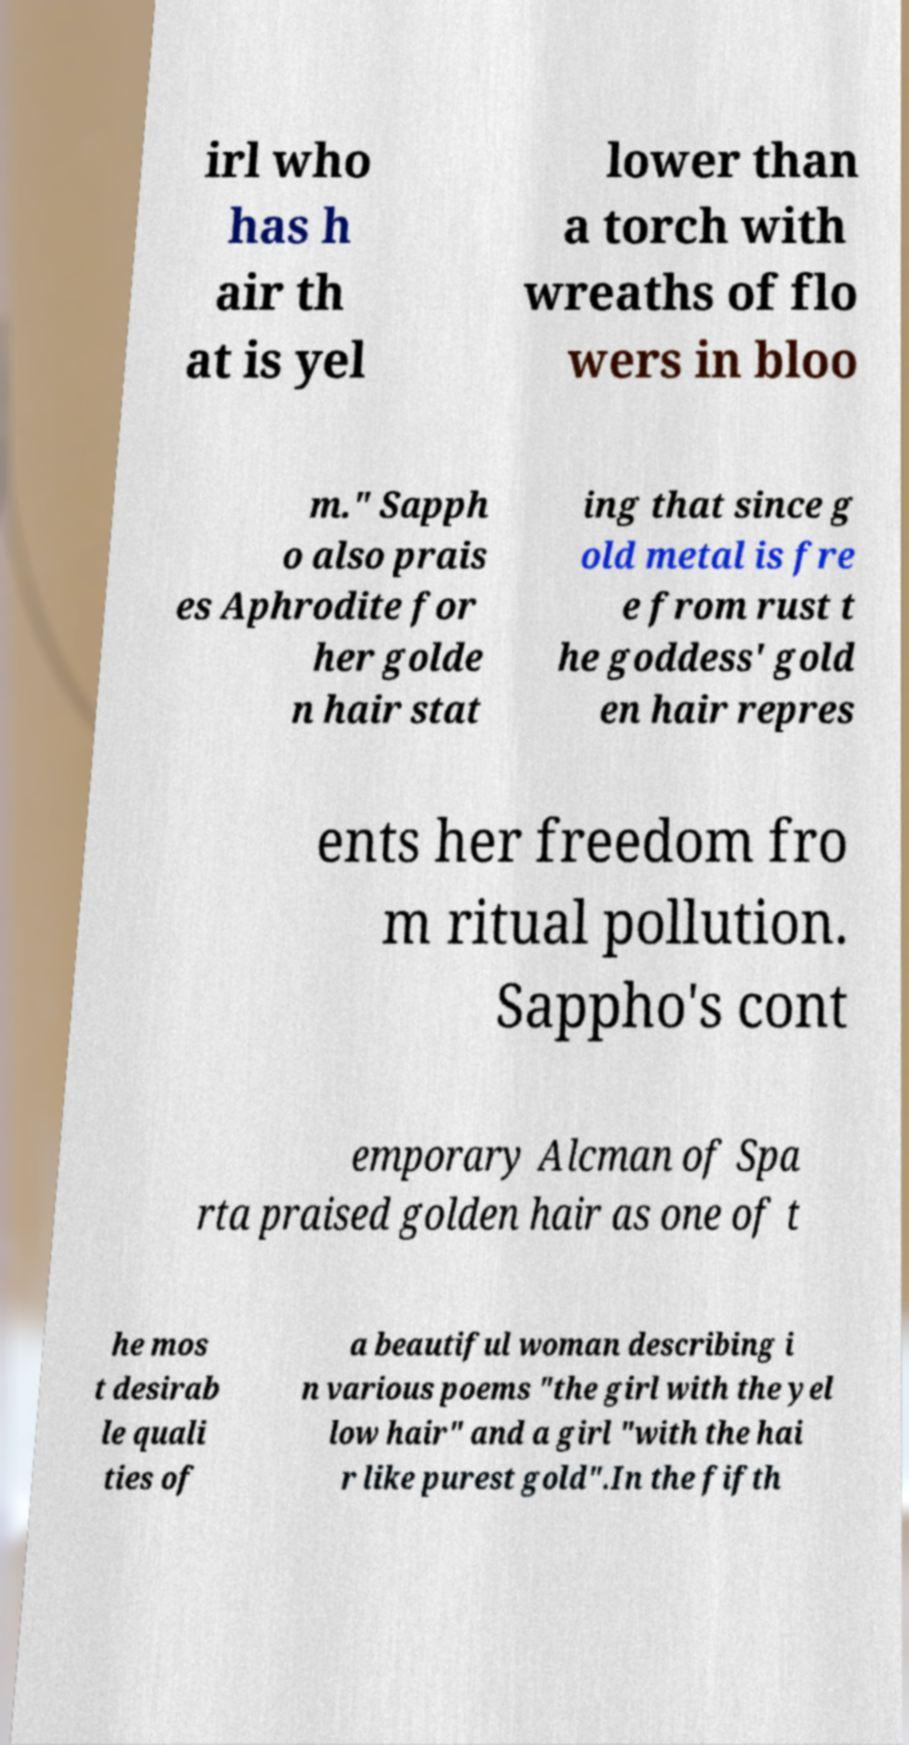Can you read and provide the text displayed in the image?This photo seems to have some interesting text. Can you extract and type it out for me? irl who has h air th at is yel lower than a torch with wreaths of flo wers in bloo m." Sapph o also prais es Aphrodite for her golde n hair stat ing that since g old metal is fre e from rust t he goddess' gold en hair repres ents her freedom fro m ritual pollution. Sappho's cont emporary Alcman of Spa rta praised golden hair as one of t he mos t desirab le quali ties of a beautiful woman describing i n various poems "the girl with the yel low hair" and a girl "with the hai r like purest gold".In the fifth 